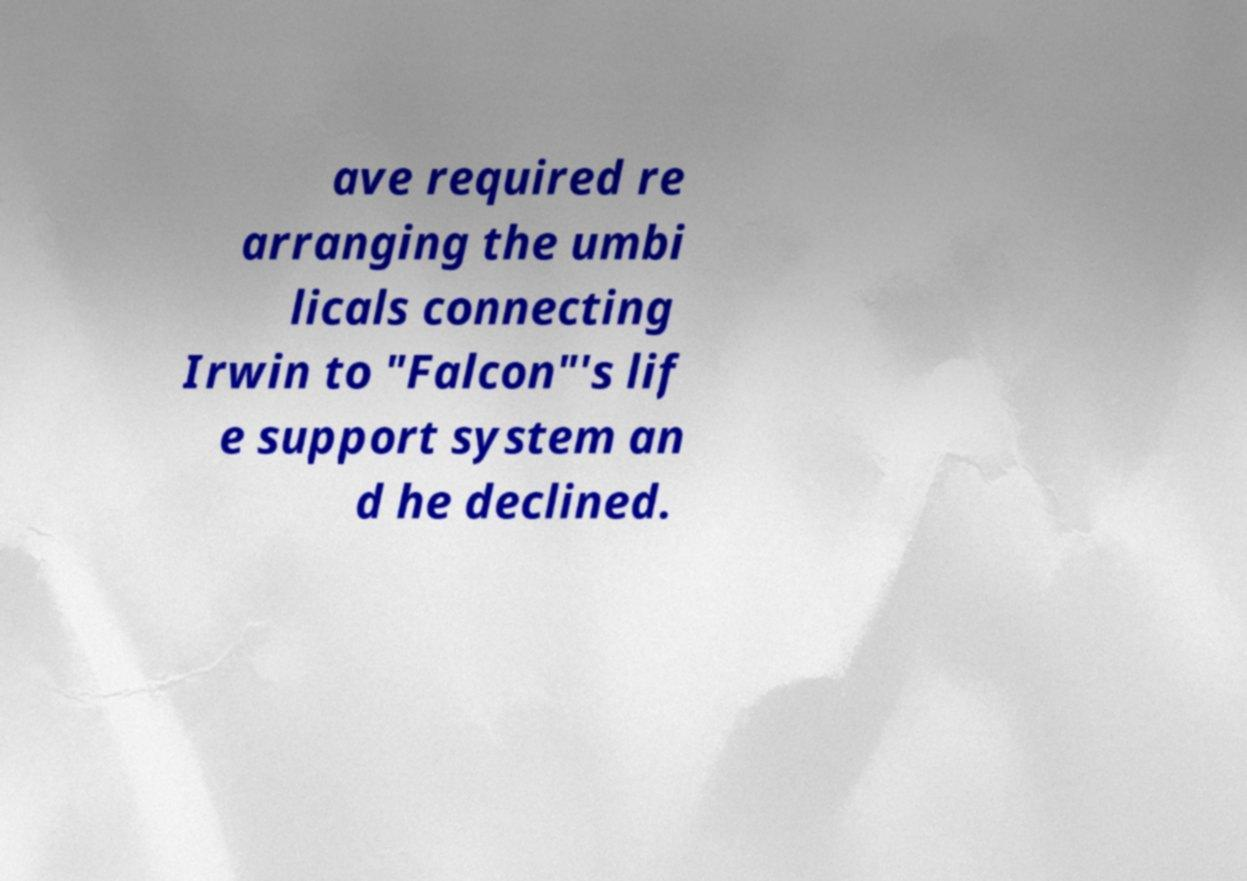Please identify and transcribe the text found in this image. ave required re arranging the umbi licals connecting Irwin to "Falcon"'s lif e support system an d he declined. 